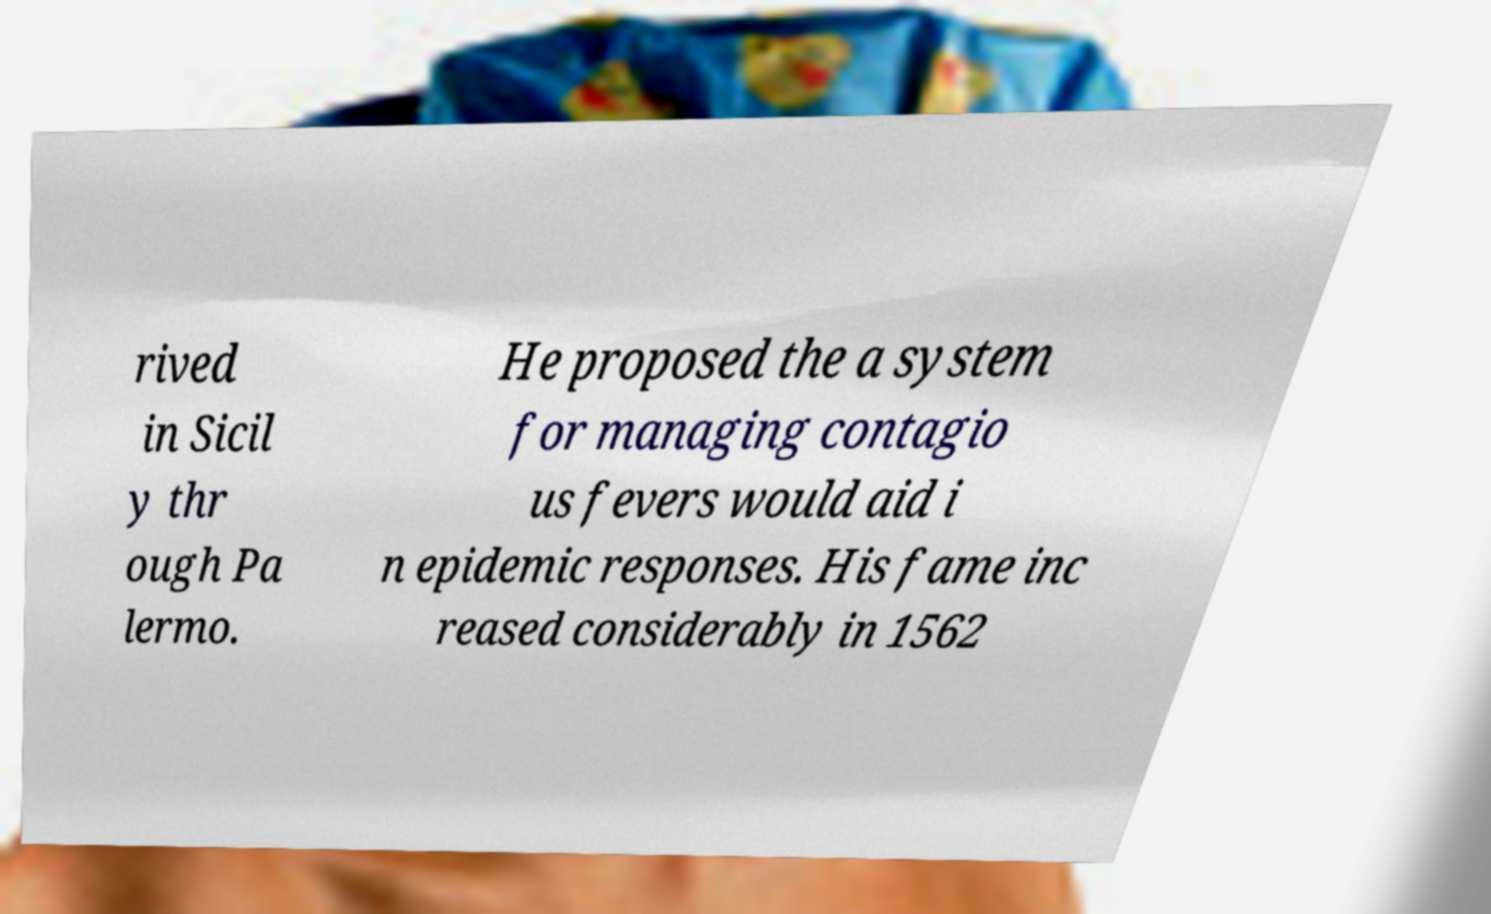Please read and relay the text visible in this image. What does it say? rived in Sicil y thr ough Pa lermo. He proposed the a system for managing contagio us fevers would aid i n epidemic responses. His fame inc reased considerably in 1562 